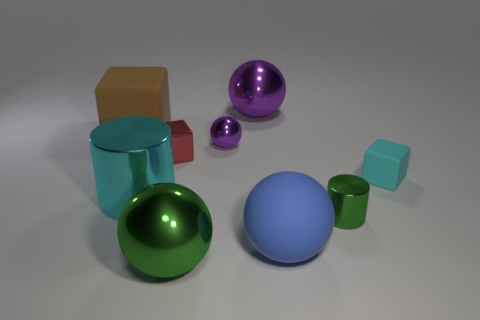Are the ball that is behind the large brown object and the large thing in front of the large rubber ball made of the same material?
Offer a terse response. Yes. Is the number of purple things that are left of the red shiny block greater than the number of big green shiny spheres on the left side of the tiny cyan thing?
Provide a succinct answer. No. There is a cyan object that is the same size as the brown object; what is its shape?
Offer a terse response. Cylinder. How many objects are large brown rubber objects or tiny things that are behind the tiny red cube?
Make the answer very short. 2. Is the color of the tiny sphere the same as the matte sphere?
Your answer should be very brief. No. How many tiny metallic cubes are on the left side of the tiny shiny cube?
Give a very brief answer. 0. What is the color of the big ball that is made of the same material as the brown block?
Provide a short and direct response. Blue. What number of matte things are either gray cylinders or red cubes?
Your answer should be very brief. 0. Is the small purple sphere made of the same material as the blue thing?
Your response must be concise. No. There is a large matte thing that is on the right side of the tiny red metal object; what shape is it?
Your response must be concise. Sphere. 